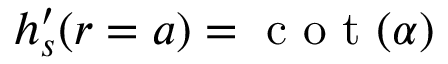Convert formula to latex. <formula><loc_0><loc_0><loc_500><loc_500>h _ { s } ^ { \prime } ( r = a ) = c o t ( \alpha )</formula> 